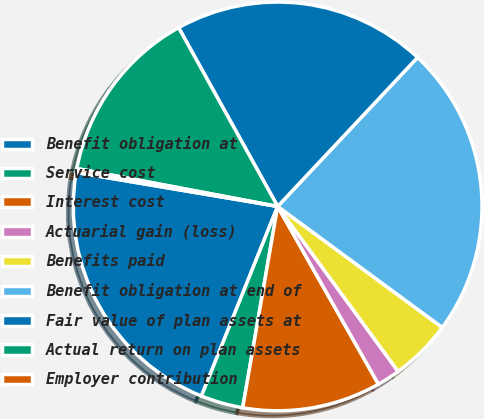Convert chart. <chart><loc_0><loc_0><loc_500><loc_500><pie_chart><fcel>Benefit obligation at<fcel>Service cost<fcel>Interest cost<fcel>Actuarial gain (loss)<fcel>Benefits paid<fcel>Benefit obligation at end of<fcel>Fair value of plan assets at<fcel>Actual return on plan assets<fcel>Employer contribution<nl><fcel>21.57%<fcel>3.35%<fcel>10.94%<fcel>1.83%<fcel>4.87%<fcel>23.09%<fcel>20.05%<fcel>13.98%<fcel>0.31%<nl></chart> 